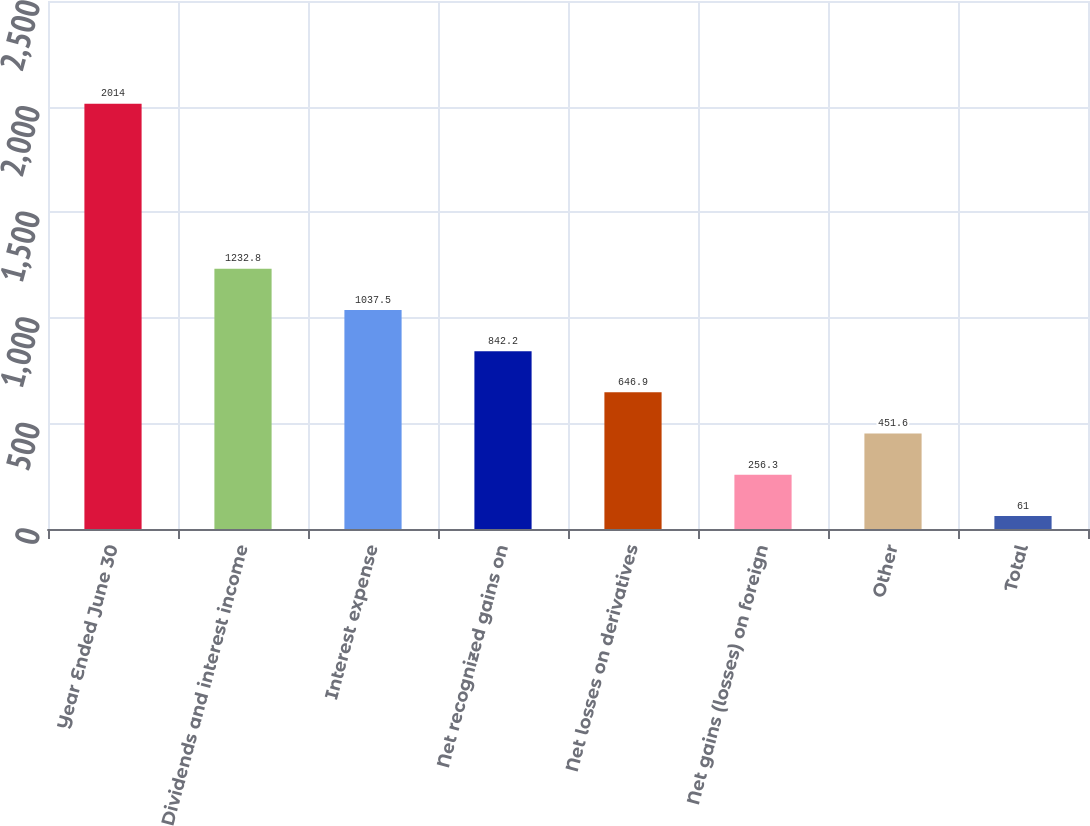Convert chart to OTSL. <chart><loc_0><loc_0><loc_500><loc_500><bar_chart><fcel>Year Ended June 30<fcel>Dividends and interest income<fcel>Interest expense<fcel>Net recognized gains on<fcel>Net losses on derivatives<fcel>Net gains (losses) on foreign<fcel>Other<fcel>Total<nl><fcel>2014<fcel>1232.8<fcel>1037.5<fcel>842.2<fcel>646.9<fcel>256.3<fcel>451.6<fcel>61<nl></chart> 